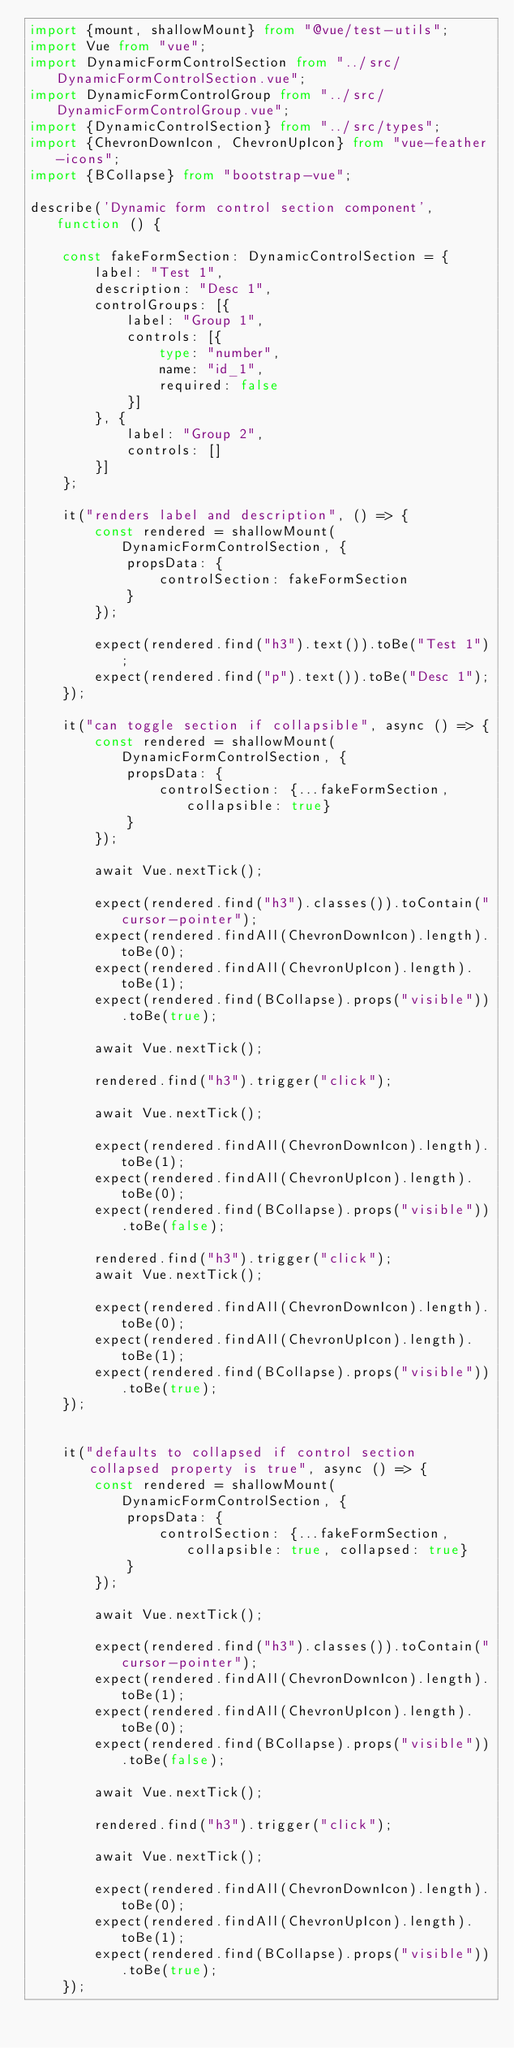<code> <loc_0><loc_0><loc_500><loc_500><_TypeScript_>import {mount, shallowMount} from "@vue/test-utils";
import Vue from "vue";
import DynamicFormControlSection from "../src/DynamicFormControlSection.vue";
import DynamicFormControlGroup from "../src/DynamicFormControlGroup.vue";
import {DynamicControlSection} from "../src/types";
import {ChevronDownIcon, ChevronUpIcon} from "vue-feather-icons";
import {BCollapse} from "bootstrap-vue";

describe('Dynamic form control section component', function () {

    const fakeFormSection: DynamicControlSection = {
        label: "Test 1",
        description: "Desc 1",
        controlGroups: [{
            label: "Group 1",
            controls: [{
                type: "number",
                name: "id_1",
                required: false
            }]
        }, {
            label: "Group 2",
            controls: []
        }]
    };

    it("renders label and description", () => {
        const rendered = shallowMount(DynamicFormControlSection, {
            propsData: {
                controlSection: fakeFormSection
            }
        });

        expect(rendered.find("h3").text()).toBe("Test 1");
        expect(rendered.find("p").text()).toBe("Desc 1");
    });

    it("can toggle section if collapsible", async () => {
        const rendered = shallowMount(DynamicFormControlSection, {
            propsData: {
                controlSection: {...fakeFormSection, collapsible: true}
            }
        });

        await Vue.nextTick();

        expect(rendered.find("h3").classes()).toContain("cursor-pointer");
        expect(rendered.findAll(ChevronDownIcon).length).toBe(0);
        expect(rendered.findAll(ChevronUpIcon).length).toBe(1);
        expect(rendered.find(BCollapse).props("visible")).toBe(true);

        await Vue.nextTick();

        rendered.find("h3").trigger("click");

        await Vue.nextTick();

        expect(rendered.findAll(ChevronDownIcon).length).toBe(1);
        expect(rendered.findAll(ChevronUpIcon).length).toBe(0);
        expect(rendered.find(BCollapse).props("visible")).toBe(false);

        rendered.find("h3").trigger("click");
        await Vue.nextTick();

        expect(rendered.findAll(ChevronDownIcon).length).toBe(0);
        expect(rendered.findAll(ChevronUpIcon).length).toBe(1);
        expect(rendered.find(BCollapse).props("visible")).toBe(true);
    });


    it("defaults to collapsed if control section collapsed property is true", async () => {
        const rendered = shallowMount(DynamicFormControlSection, {
            propsData: {
                controlSection: {...fakeFormSection, collapsible: true, collapsed: true}
            }
        });

        await Vue.nextTick();

        expect(rendered.find("h3").classes()).toContain("cursor-pointer");
        expect(rendered.findAll(ChevronDownIcon).length).toBe(1);
        expect(rendered.findAll(ChevronUpIcon).length).toBe(0);
        expect(rendered.find(BCollapse).props("visible")).toBe(false);

        await Vue.nextTick();

        rendered.find("h3").trigger("click");

        await Vue.nextTick();

        expect(rendered.findAll(ChevronDownIcon).length).toBe(0);
        expect(rendered.findAll(ChevronUpIcon).length).toBe(1);
        expect(rendered.find(BCollapse).props("visible")).toBe(true);
    });
</code> 